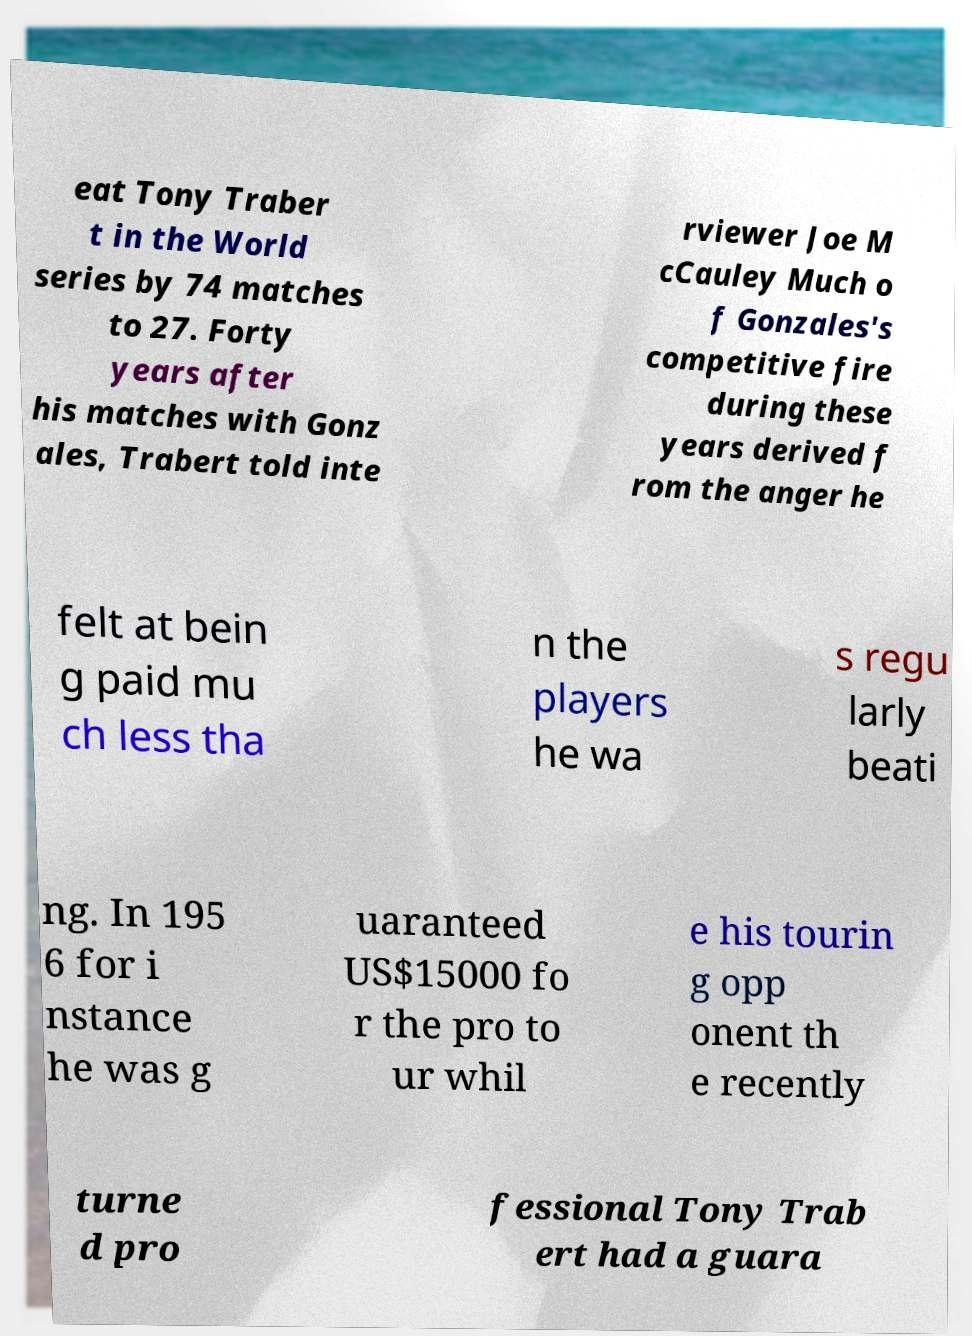Could you assist in decoding the text presented in this image and type it out clearly? eat Tony Traber t in the World series by 74 matches to 27. Forty years after his matches with Gonz ales, Trabert told inte rviewer Joe M cCauley Much o f Gonzales's competitive fire during these years derived f rom the anger he felt at bein g paid mu ch less tha n the players he wa s regu larly beati ng. In 195 6 for i nstance he was g uaranteed US$15000 fo r the pro to ur whil e his tourin g opp onent th e recently turne d pro fessional Tony Trab ert had a guara 